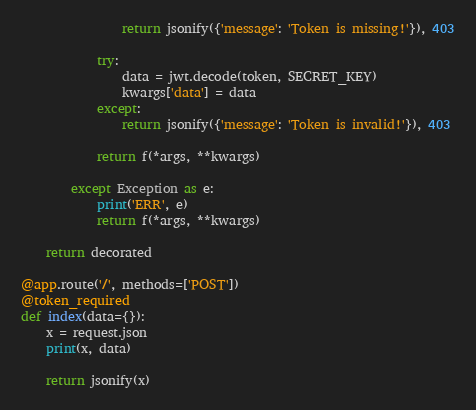Convert code to text. <code><loc_0><loc_0><loc_500><loc_500><_Python_>				return jsonify({'message': 'Token is missing!'}), 403

			try:
				data = jwt.decode(token, SECRET_KEY)
				kwargs['data'] = data
			except:
				return jsonify({'message': 'Token is invalid!'}), 403

			return f(*args, **kwargs)

		except Exception as e:
			print('ERR', e)
			return f(*args, **kwargs)

	return decorated

@app.route('/', methods=['POST'])
@token_required
def index(data={}):
	x = request.json
	print(x, data)

	return jsonify(x)</code> 